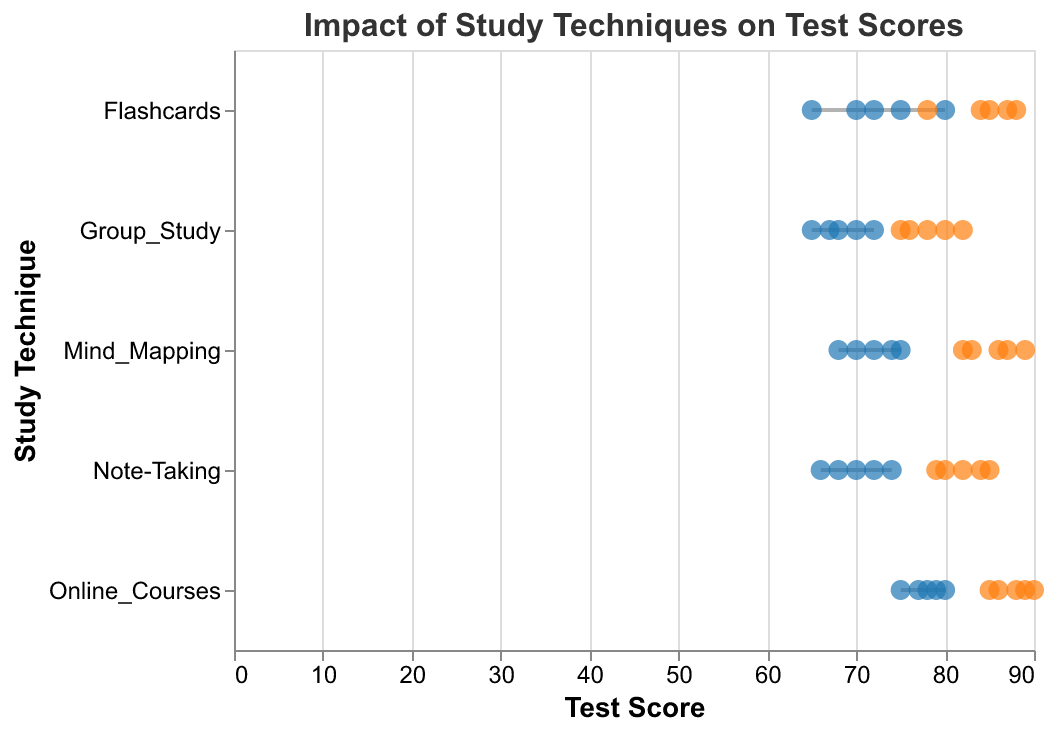What is the title of the plot? The title can be found at the top of the plot. It reads "Impact of Study Techniques on Test Scores".
Answer: Impact of Study Techniques on Test Scores What are the two different colors of the points used in the plot, and what do they represent? There are blue and orange points in the plot. Blue points represent pre-test scores, and orange points represent post-test scores.
Answer: Blue: Pre-Test Scores, Orange: Post-Test Scores How are the five study techniques distributed along the y-axis? The y-axis lists the study techniques from top to bottom. They are Flashcards, Mind_Mapping, Group_Study, Online_Courses, and Note-Taking.
Answer: Flashcards, Mind_Mapping, Group_Study, Online_Courses, Note-Taking Which study technique had the highest post-test score, and what was the score? Identify the orange point with the highest value. The highest post-test score is for the study technique Online_Courses, and the score is 90.
Answer: Online_Courses, 90 What is the difference between the pre-test and post-test scores for the study technique "Group_Study" with the highest post-test score? Identify the Group_Study point with the highest post-test score, which is 82. The corresponding pre-test score is 72. The difference is 82 - 72.
Answer: 10 What is the average post-test score for the study technique "Mind_Mapping"? Find the post-test scores for Mind_Mapping: 82, 86, 89, 83, 87. Calculate the average: (82 + 86 + 89 + 83 + 87) / 5.
Answer: 85.4 Which study technique showed the smallest improvement from pre-test to post-test on average? Calculate the average improvement for each technique and compare. Flashcards: 18.6, Mind_Mapping: 13.8, Group_Study: 10, Online_Courses: 9.4, Note-Taking: 13.4. Group_Study has the smallest average improvement.
Answer: Group_Study How many total data points are represented in the plot? Count the number of data entries for each study technique and sum them up: 5 (Flashcards) + 5 (Mind_Mapping) + 5 (Group_Study) + 5 (Online_Courses) + 5 (Note-Taking).
Answer: 25 Which study technique had the most consistent post-test scores, and what was its range? Consistent means smallest range of post-test scores. Find the range for each technique: Flashcards (88-78=10), Mind_Mapping (89-82=7), Group_Study (82-75=7), Online_Courses (90-85=5), Note-Taking (85-79=6). Online_Courses had the smallest range.
Answer: Online_Courses, 5 What is the minimum pre-test score recorded for the study technique "Note-Taking"? Identify and compare all pre-test scores for Note-Taking. The scores are 66, 70, 72, 74, and 68. The minimum score is 66.
Answer: 66 